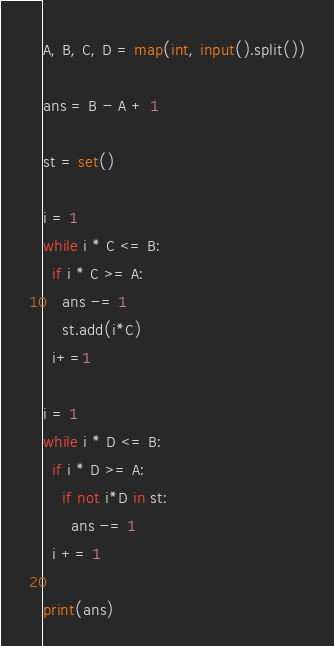Convert code to text. <code><loc_0><loc_0><loc_500><loc_500><_Python_>A, B, C, D = map(int, input().split())

ans = B - A + 1

st = set()

i = 1
while i * C <= B:
  if i * C >= A:
    ans -= 1
    st.add(i*C)
  i+=1
  
i = 1
while i * D <= B:
  if i * D >= A:  
    if not i*D in st:
      ans -= 1
  i += 1
  
print(ans)</code> 